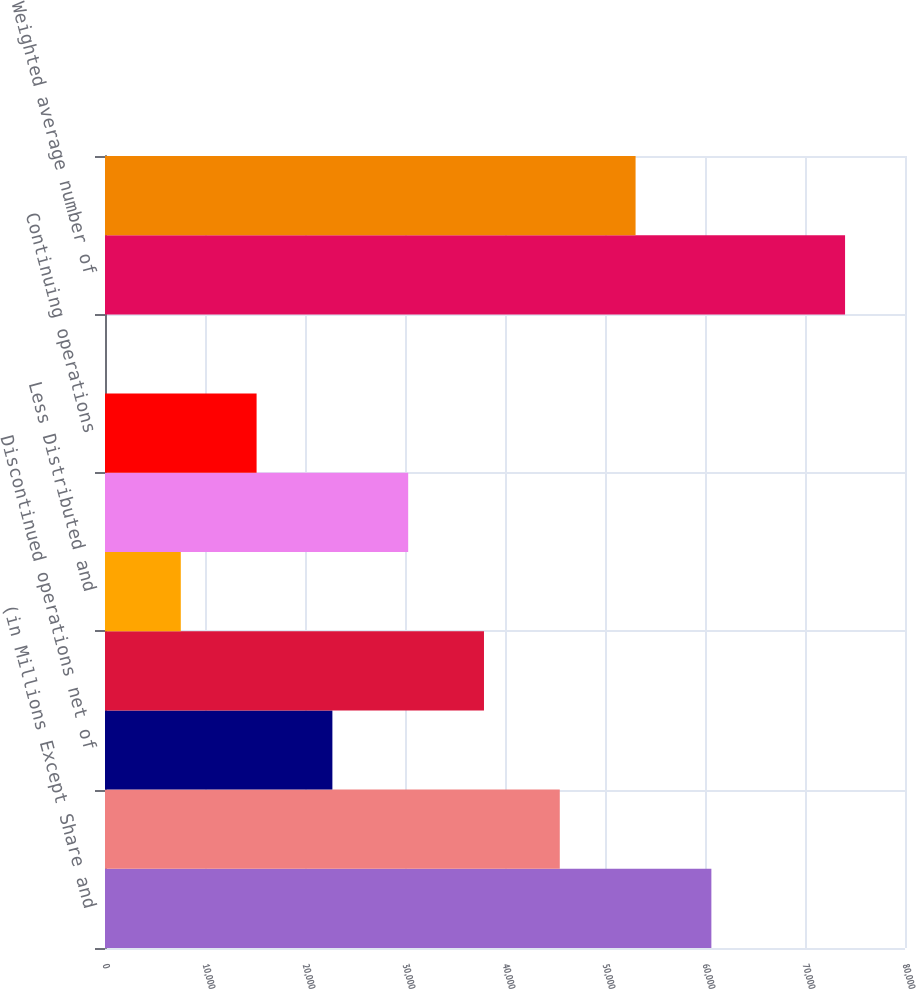Convert chart. <chart><loc_0><loc_0><loc_500><loc_500><bar_chart><fcel>(in Millions Except Share and<fcel>Income from continuing<fcel>Discontinued operations net of<fcel>Net income<fcel>Less Distributed and<fcel>Net income allocable to common<fcel>Continuing operations<fcel>Discontinued operations<fcel>Weighted average number of<fcel>Weighted average additional<nl><fcel>60636.9<fcel>45477.8<fcel>22739<fcel>37898.2<fcel>7579.91<fcel>30318.6<fcel>15159.5<fcel>0.34<fcel>74006<fcel>53057.3<nl></chart> 